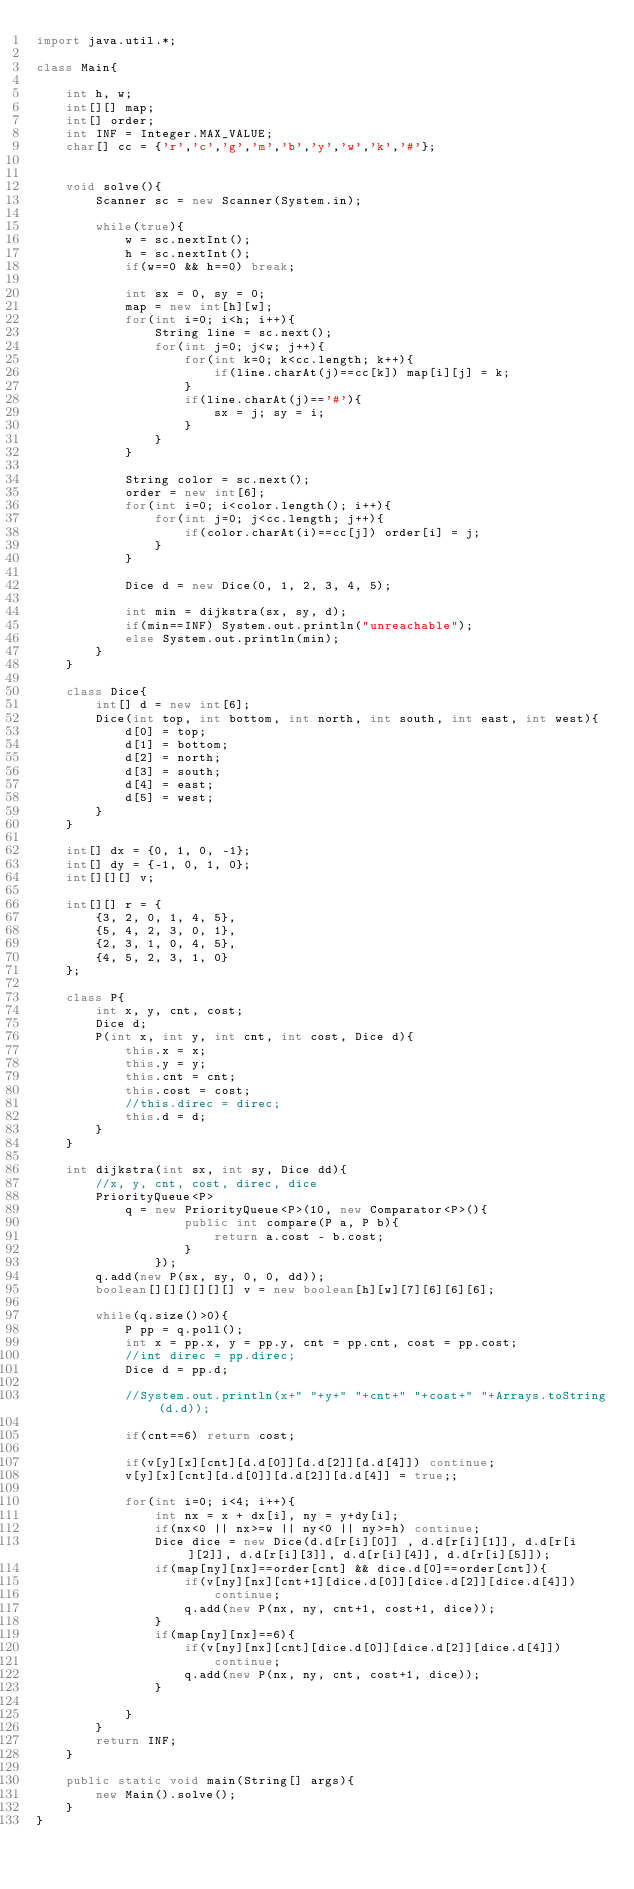<code> <loc_0><loc_0><loc_500><loc_500><_Java_>import java.util.*;
 
class Main{
     
    int h, w;
    int[][] map;
    int[] order;
    int INF = Integer.MAX_VALUE;
    char[] cc = {'r','c','g','m','b','y','w','k','#'};

     
    void solve(){
        Scanner sc = new Scanner(System.in);
         
        while(true){
            w = sc.nextInt();
            h = sc.nextInt();
            if(w==0 && h==0) break;
             
            int sx = 0, sy = 0;
            map = new int[h][w];
            for(int i=0; i<h; i++){
                String line = sc.next();
                for(int j=0; j<w; j++){
                    for(int k=0; k<cc.length; k++){
                        if(line.charAt(j)==cc[k]) map[i][j] = k;
                    }
                    if(line.charAt(j)=='#'){
                        sx = j; sy = i;
                    }
                }
            }
             
            String color = sc.next();
            order = new int[6];
            for(int i=0; i<color.length(); i++){
                for(int j=0; j<cc.length; j++){
                    if(color.charAt(i)==cc[j]) order[i] = j;
                }
            }

            Dice d = new Dice(0, 1, 2, 3, 4, 5);
 
            int min = dijkstra(sx, sy, d);
            if(min==INF) System.out.println("unreachable");
            else System.out.println(min);
        }
    }
     
    class Dice{
        int[] d = new int[6];
        Dice(int top, int bottom, int north, int south, int east, int west){
            d[0] = top;
            d[1] = bottom;
            d[2] = north;
            d[3] = south;
            d[4] = east;
            d[5] = west;
        }
    }
     
    int[] dx = {0, 1, 0, -1};
    int[] dy = {-1, 0, 1, 0};
    int[][][] v;
     
    int[][] r = {
        {3, 2, 0, 1, 4, 5},
        {5, 4, 2, 3, 0, 1},
        {2, 3, 1, 0, 4, 5},
        {4, 5, 2, 3, 1, 0}
    };
     
    class P{
        int x, y, cnt, cost;
        Dice d;
        P(int x, int y, int cnt, int cost, Dice d){
            this.x = x;
            this.y = y;
            this.cnt = cnt;
            this.cost = cost;
            //this.direc = direc;
            this.d = d;
        }
    }
 
    int dijkstra(int sx, int sy, Dice dd){
        //x, y, cnt, cost, direc, dice
        PriorityQueue<P> 
            q = new PriorityQueue<P>(10, new Comparator<P>(){
                    public int compare(P a, P b){
                        return a.cost - b.cost;
                    }
                });
        q.add(new P(sx, sy, 0, 0, dd));
        boolean[][][][][][] v = new boolean[h][w][7][6][6][6];
 
        while(q.size()>0){
            P pp = q.poll();
            int x = pp.x, y = pp.y, cnt = pp.cnt, cost = pp.cost;
            //int direc = pp.direc;
            Dice d = pp.d;
 
            //System.out.println(x+" "+y+" "+cnt+" "+cost+" "+Arrays.toString(d.d));
 
            if(cnt==6) return cost;
 
            if(v[y][x][cnt][d.d[0]][d.d[2]][d.d[4]]) continue;
            v[y][x][cnt][d.d[0]][d.d[2]][d.d[4]] = true;;
 
            for(int i=0; i<4; i++){
                int nx = x + dx[i], ny = y+dy[i];
                if(nx<0 || nx>=w || ny<0 || ny>=h) continue;
                Dice dice = new Dice(d.d[r[i][0]] , d.d[r[i][1]], d.d[r[i][2]], d.d[r[i][3]], d.d[r[i][4]], d.d[r[i][5]]);
                if(map[ny][nx]==order[cnt] && dice.d[0]==order[cnt]){
                    if(v[ny][nx][cnt+1][dice.d[0]][dice.d[2]][dice.d[4]])
                        continue;
                    q.add(new P(nx, ny, cnt+1, cost+1, dice));
                }
                if(map[ny][nx]==6){
                    if(v[ny][nx][cnt][dice.d[0]][dice.d[2]][dice.d[4]])
                        continue;
                    q.add(new P(nx, ny, cnt, cost+1, dice));
                }
                 
            }
        }
        return INF;
    }
     
    public static void main(String[] args){
        new Main().solve();
    }
}</code> 